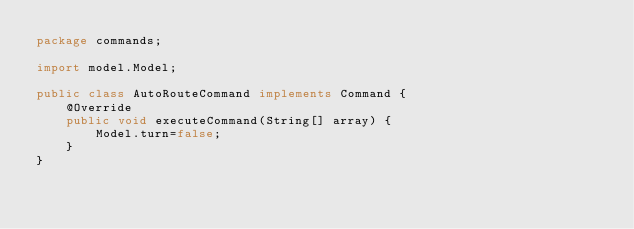Convert code to text. <code><loc_0><loc_0><loc_500><loc_500><_Java_>package commands;

import model.Model;

public class AutoRouteCommand implements Command {
    @Override
    public void executeCommand(String[] array) {
        Model.turn=false;
    }
}
</code> 